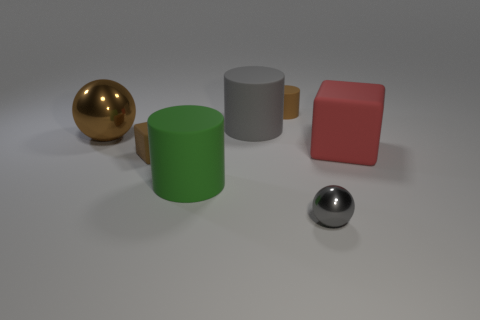Subtract all purple spheres. Subtract all gray cylinders. How many spheres are left? 2 Add 2 small brown cubes. How many objects exist? 9 Subtract all spheres. How many objects are left? 5 Add 2 balls. How many balls exist? 4 Subtract 1 brown cubes. How many objects are left? 6 Subtract all brown metallic balls. Subtract all gray matte objects. How many objects are left? 5 Add 3 small gray metallic balls. How many small gray metallic balls are left? 4 